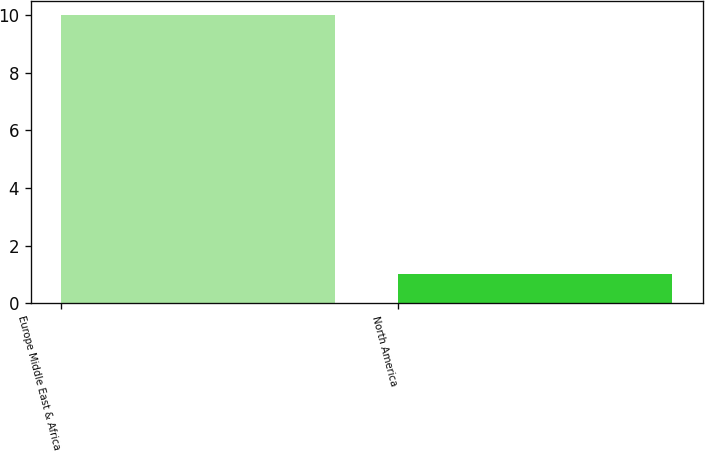Convert chart. <chart><loc_0><loc_0><loc_500><loc_500><bar_chart><fcel>Europe Middle East & Africa<fcel>North America<nl><fcel>10<fcel>1<nl></chart> 